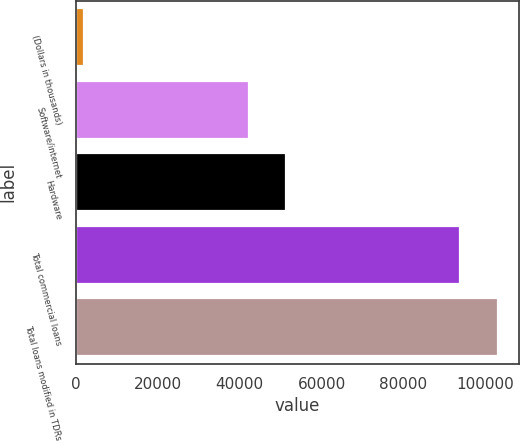Convert chart to OTSL. <chart><loc_0><loc_0><loc_500><loc_500><bar_chart><fcel>(Dollars in thousands)<fcel>Software/internet<fcel>Hardware<fcel>Total commercial loans<fcel>Total loans modified in TDRs<nl><fcel>2017<fcel>42184<fcel>51366.6<fcel>93843<fcel>103026<nl></chart> 